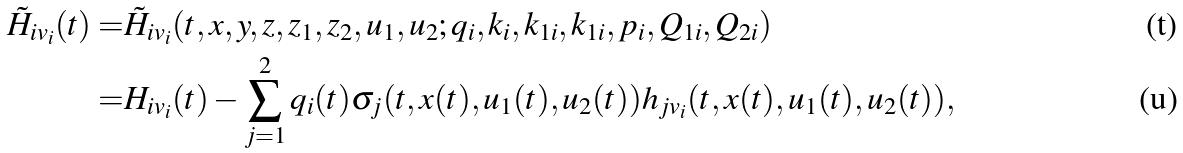<formula> <loc_0><loc_0><loc_500><loc_500>\tilde { H } _ { i v _ { i } } ( t ) = & \tilde { H } _ { i { v _ { i } } } ( t , x , y , z , z _ { 1 } , z _ { 2 } , u _ { 1 } , u _ { 2 } ; q _ { i } , k _ { i } , k _ { 1 i } , k _ { 1 i } , p _ { i } , Q _ { 1 i } , Q _ { 2 i } ) \\ = & H _ { i v _ { i } } ( t ) - \sum _ { j = 1 } ^ { 2 } q _ { i } ( t ) \sigma _ { j } ( t , x ( t ) , u _ { 1 } ( t ) , u _ { 2 } ( t ) ) h _ { j v _ { i } } ( t , x ( t ) , u _ { 1 } ( t ) , u _ { 2 } ( t ) ) ,</formula> 